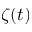<formula> <loc_0><loc_0><loc_500><loc_500>\zeta ( t )</formula> 